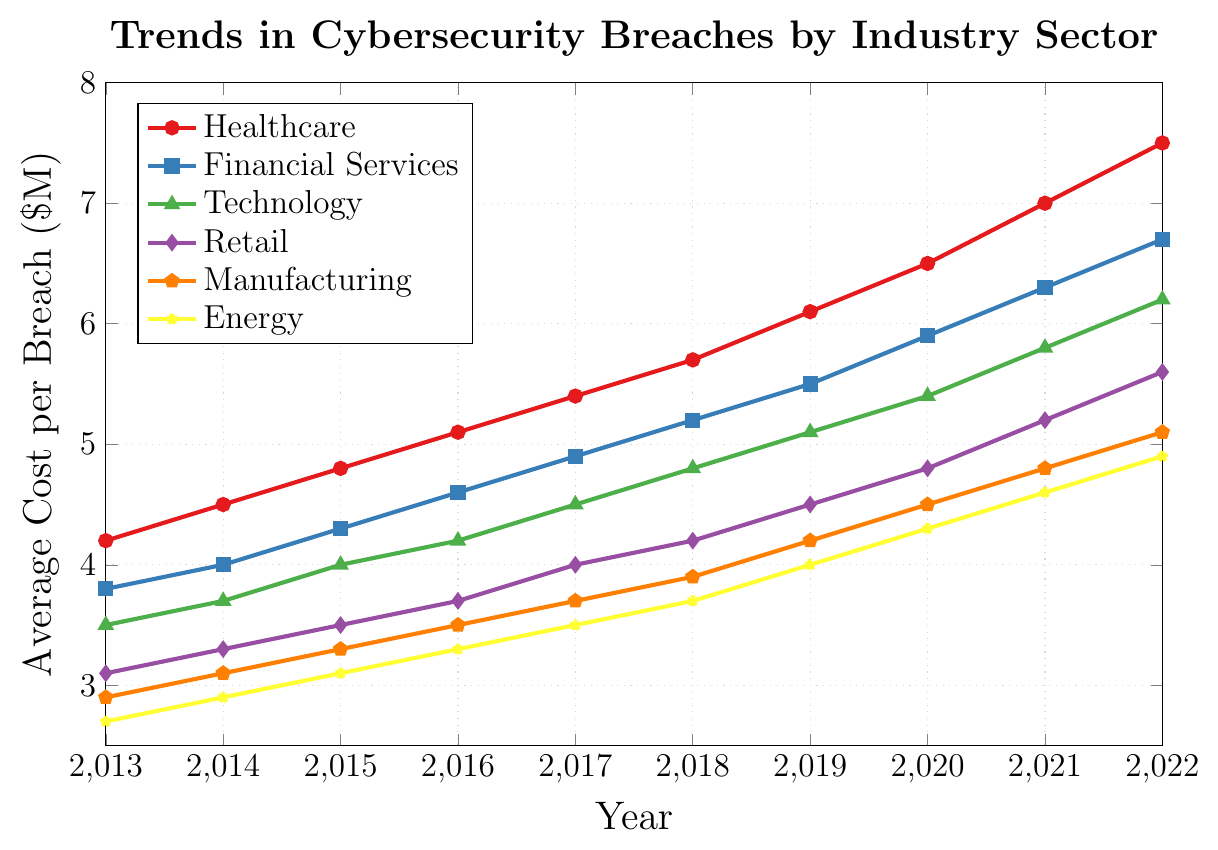Which industry sector had the highest average cost per breach in 2022? The Healthcare sector shows the highest point on the line chart at the year 2022.
Answer: Healthcare Which two industry sectors had the smallest increase in the average cost per breach from 2013 to 2022? By examining the rise in each line from 2013 to 2022, the Retail (from 3.1 to 5.6) and Energy (from 2.7 to 4.9) sectors have the smallest increases compared to others.
Answer: Retail and Energy What's the average cost per breach in the Technology sector in 2017 and 2022 combined? The values for Technology in 2017 and 2022 are 4.5 and 6.2 respectively. The sum is 4.5 + 6.2 = 10.7.
Answer: 10.7 By how much did the average cost per breach in the Manufacturing sector increase from 2013 to 2020? The values are 2.9 in 2013 and 4.5 in 2020 for the Manufacturing sector. The increase is 4.5 - 2.9 = 1.6.
Answer: 1.6 Which industry sector had the lowest average cost per breach throughout the entire period? Across all years, the Energy sector maintains the lowest points on the line chart.
Answer: Energy How does the trend in the Financial Services sector compare to the Retail sector over the last decade? Both sectors show an increasing trend, but Financial Services rise at a faster rate, with values moving from 3.8 to 6.7, while Retail moves from 3.1 to 5.6.
Answer: Financial Services increased more rapidly Which sector saw the highest increase in the average cost per breach from 2020 to 2022? By comparing the rise in each line from 2020 to 2022, the Healthcare sector increases from 6.5 to 7.5, which is the largest increase of 1.0.
Answer: Healthcare Is the average cost per breach in 2021 higher in the Technology sector or the Retail sector? In 2021, Technology is 5.8, and Retail is 5.2. Thus, Technology is higher.
Answer: Technology What is the difference in the average cost per breach between the Healthcare and Energy sectors in 2015? Healthcare is 4.8 and Energy is 3.1 in 2015. The difference is 4.8 - 3.1 = 1.7.
Answer: 1.7 Calculate the average cost per breach across all sectors for the year 2019. The values in 2019 are Healthcare: 6.1, Financial Services: 5.5, Technology: 5.1, Retail: 4.5, Manufacturing: 4.2, and Energy: 4.0. Their sum is 6.1 + 5.5 + 5.1 + 4.5 + 4.2 + 4.0 = 29.4. The average is 29.4 / 6 = 4.9.
Answer: 4.9 